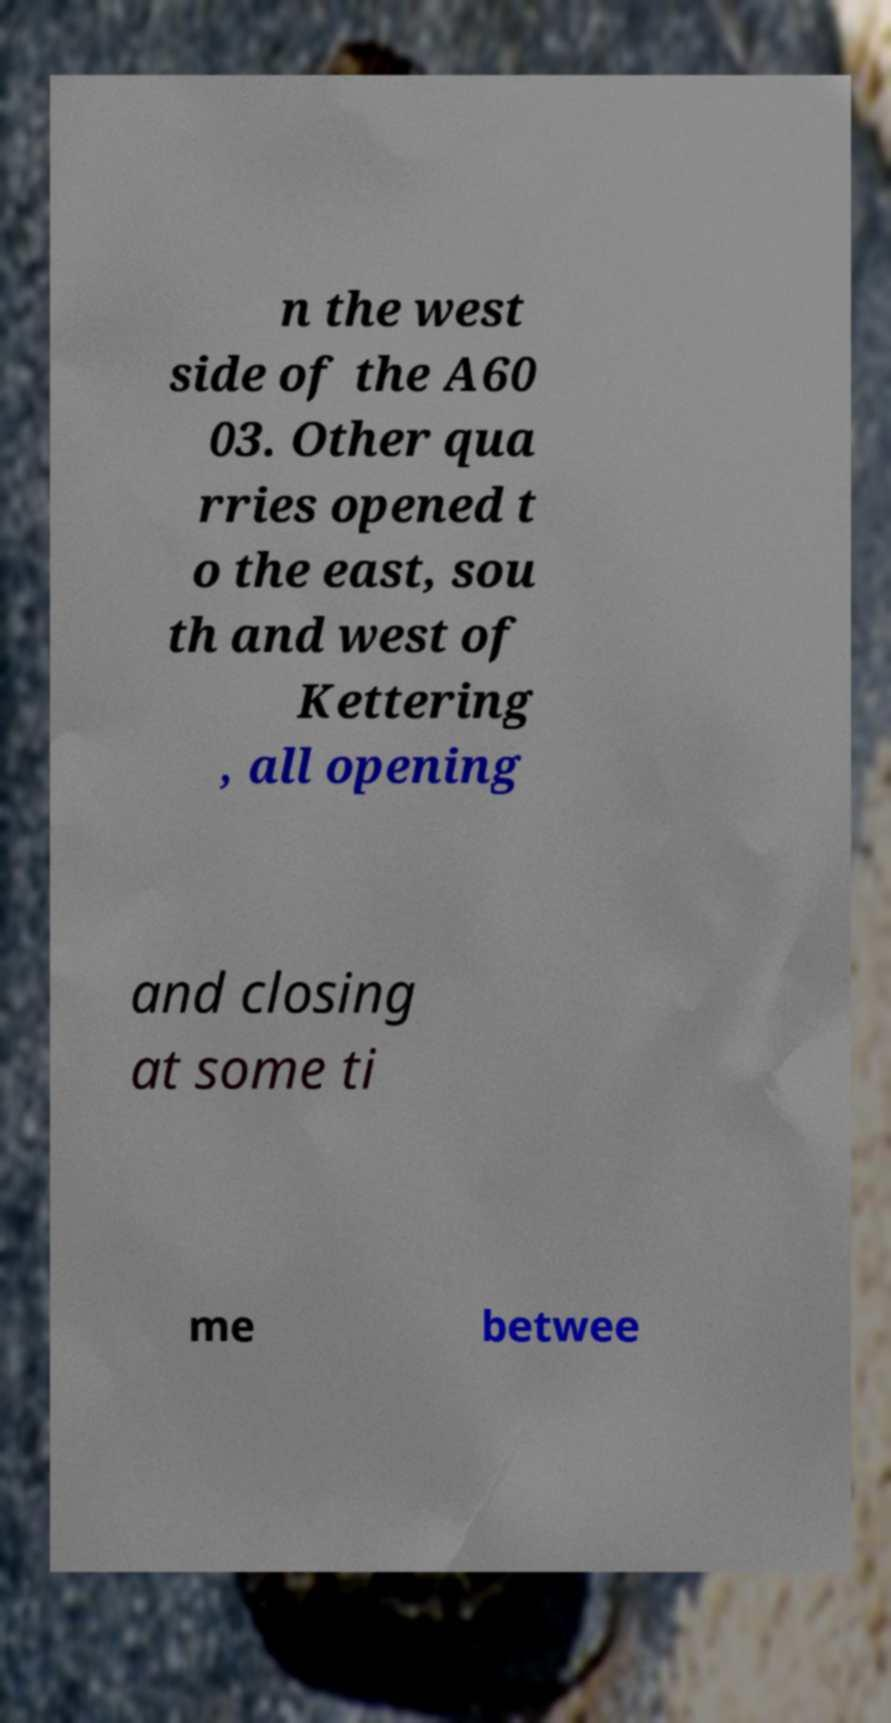Please identify and transcribe the text found in this image. n the west side of the A60 03. Other qua rries opened t o the east, sou th and west of Kettering , all opening and closing at some ti me betwee 